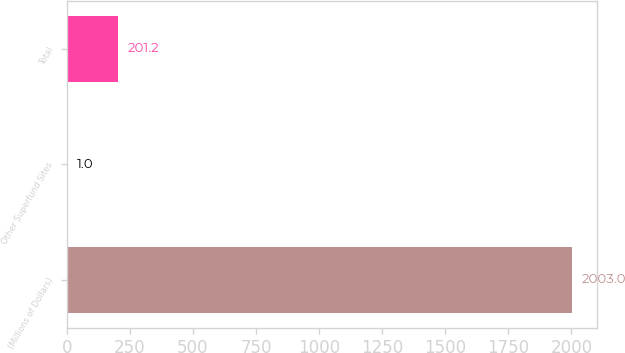Convert chart. <chart><loc_0><loc_0><loc_500><loc_500><bar_chart><fcel>(Millions of Dollars)<fcel>Other Superfund Sites<fcel>Total<nl><fcel>2003<fcel>1<fcel>201.2<nl></chart> 